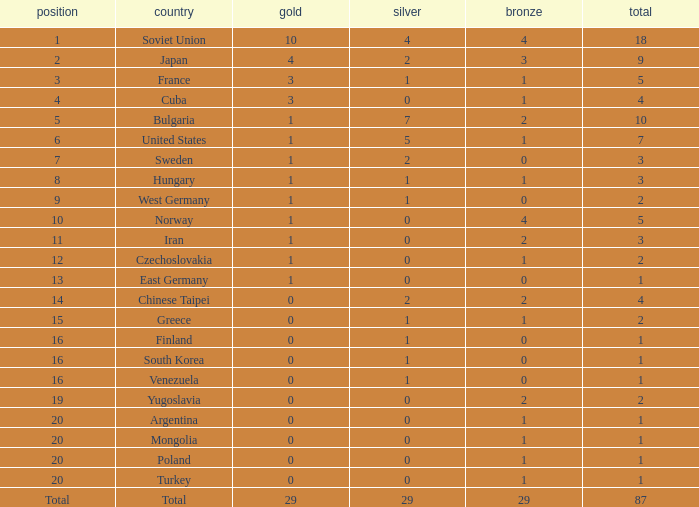What is the average number of bronze medals for total of all nations? 29.0. 